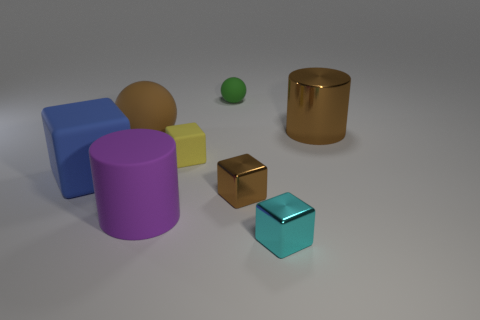Subtract all tiny rubber cubes. How many cubes are left? 3 Subtract all brown cylinders. How many cylinders are left? 1 Subtract all cylinders. How many objects are left? 6 Subtract 1 balls. How many balls are left? 1 Add 5 metal objects. How many metal objects exist? 8 Add 1 brown objects. How many objects exist? 9 Subtract 0 red balls. How many objects are left? 8 Subtract all red balls. Subtract all cyan cubes. How many balls are left? 2 Subtract all green spheres. How many purple cylinders are left? 1 Subtract all green things. Subtract all blocks. How many objects are left? 3 